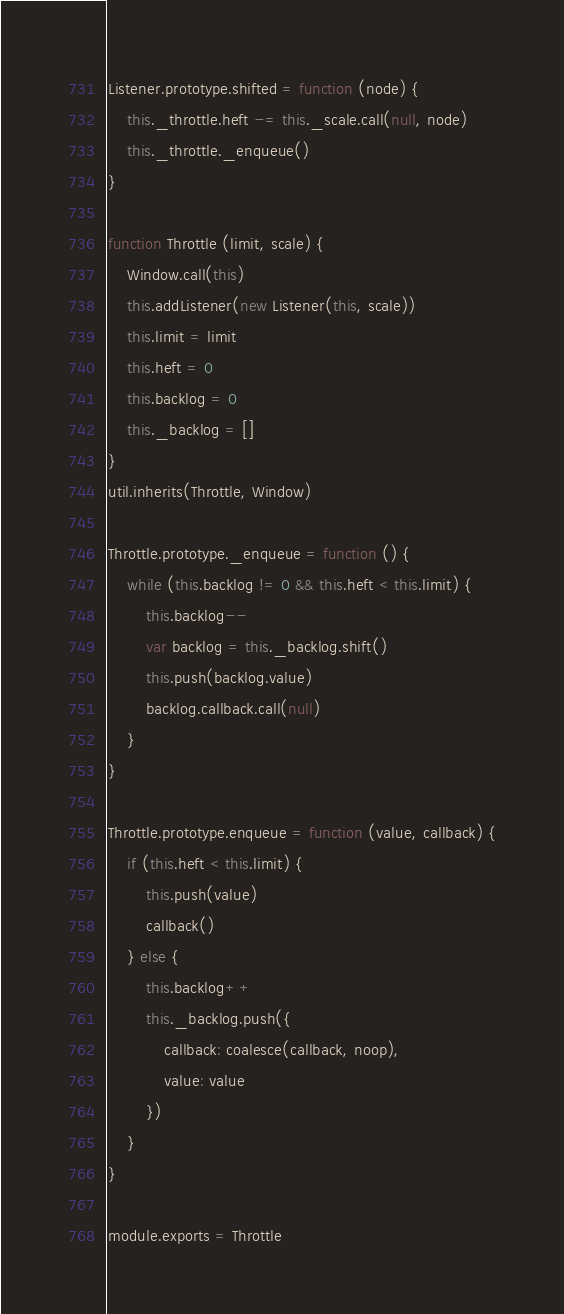Convert code to text. <code><loc_0><loc_0><loc_500><loc_500><_JavaScript_>
Listener.prototype.shifted = function (node) {
    this._throttle.heft -= this._scale.call(null, node)
    this._throttle._enqueue()
}

function Throttle (limit, scale) {
    Window.call(this)
    this.addListener(new Listener(this, scale))
    this.limit = limit
    this.heft = 0
    this.backlog = 0
    this._backlog = []
}
util.inherits(Throttle, Window)

Throttle.prototype._enqueue = function () {
    while (this.backlog != 0 && this.heft < this.limit) {
        this.backlog--
        var backlog = this._backlog.shift()
        this.push(backlog.value)
        backlog.callback.call(null)
    }
}

Throttle.prototype.enqueue = function (value, callback) {
    if (this.heft < this.limit) {
        this.push(value)
        callback()
    } else {
        this.backlog++
        this._backlog.push({
            callback: coalesce(callback, noop),
            value: value
        })
    }
}

module.exports = Throttle
</code> 